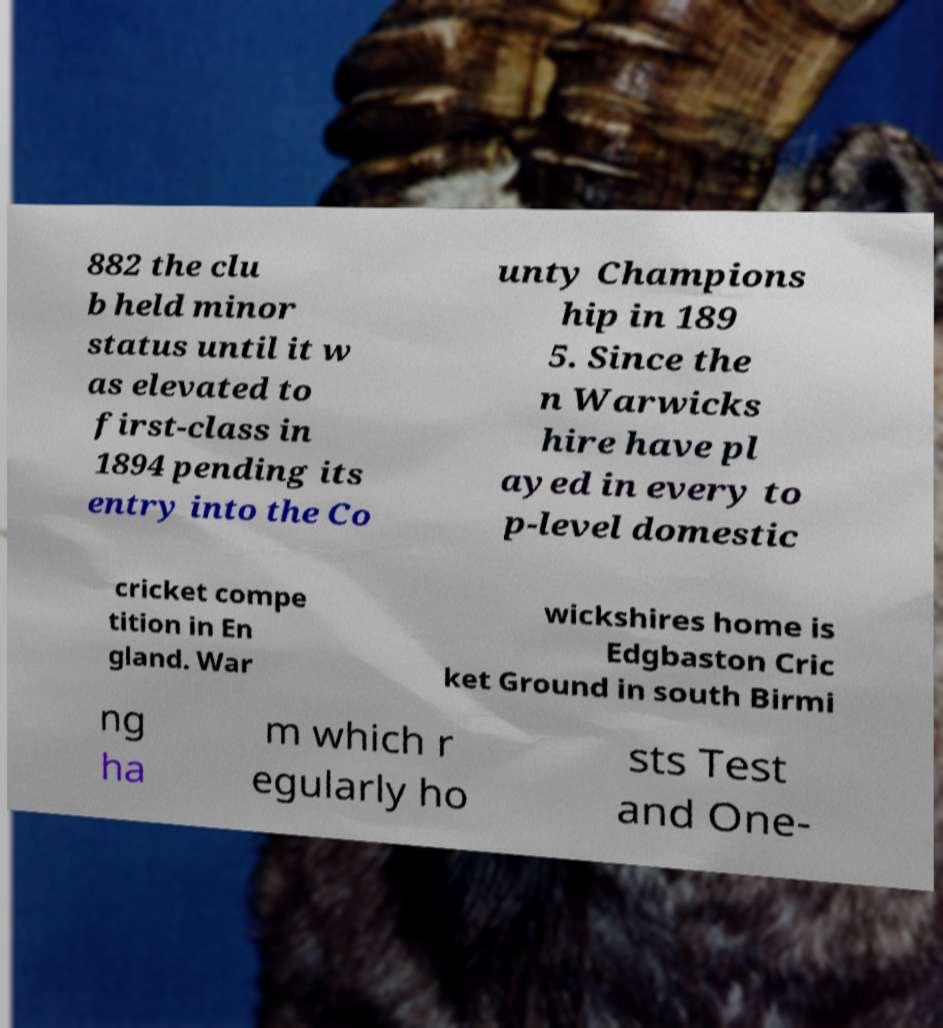Please read and relay the text visible in this image. What does it say? 882 the clu b held minor status until it w as elevated to first-class in 1894 pending its entry into the Co unty Champions hip in 189 5. Since the n Warwicks hire have pl ayed in every to p-level domestic cricket compe tition in En gland. War wickshires home is Edgbaston Cric ket Ground in south Birmi ng ha m which r egularly ho sts Test and One- 